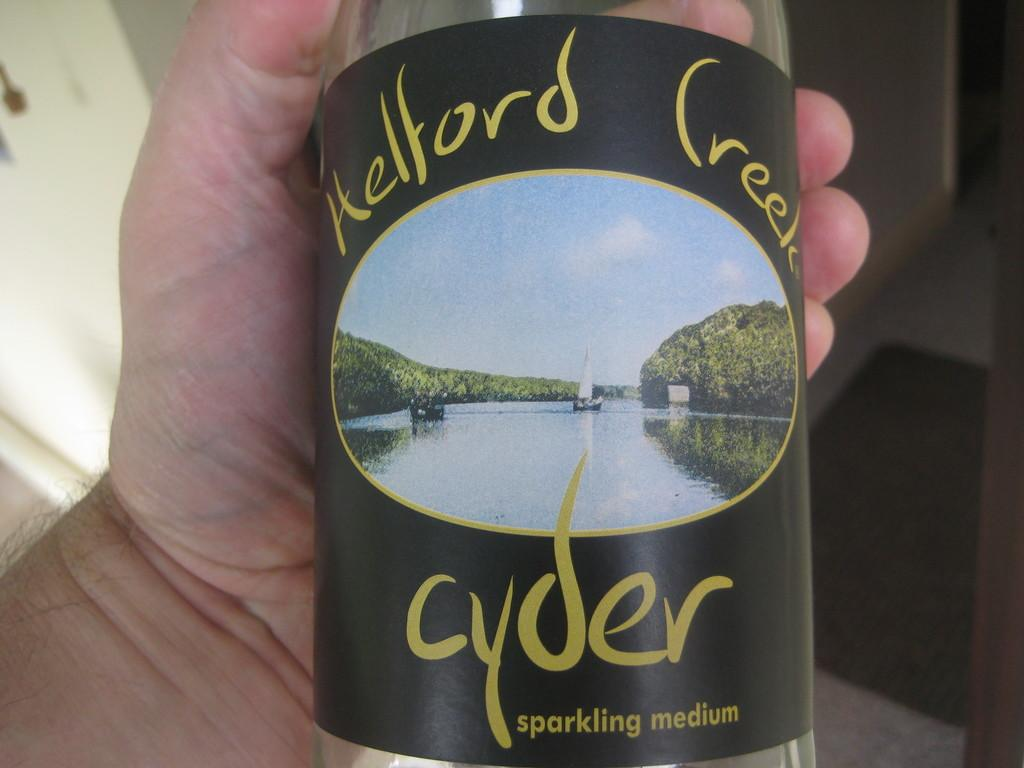What is the main subject of the image? There is a person in the image. What is the person holding in the image? The person is holding a bottle. Can you describe the design on the bottle? The design on the bottle features sky, water, a boat, and trees. How many trains can be seen in the image? There are no trains present in the image. What type of scissors is the person using in the image? There are no scissors present in the image. 